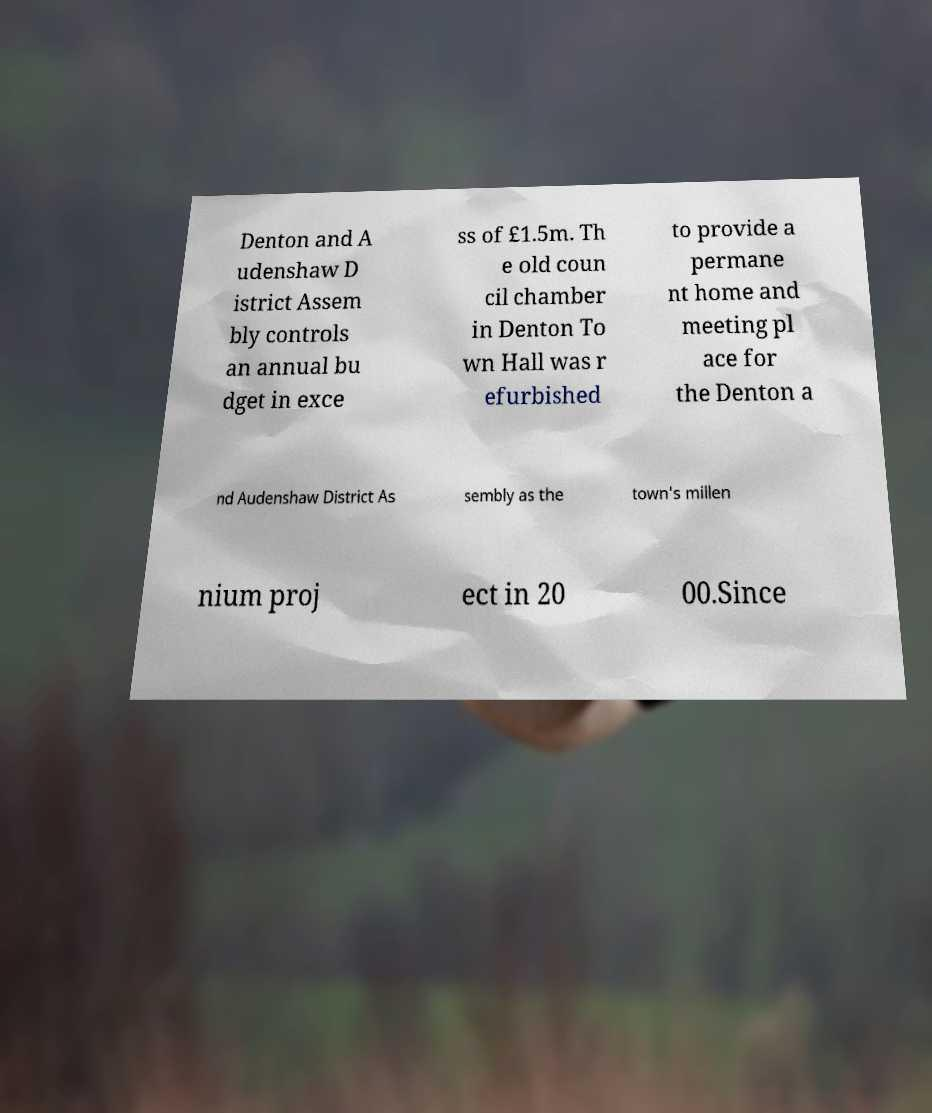Can you accurately transcribe the text from the provided image for me? Denton and A udenshaw D istrict Assem bly controls an annual bu dget in exce ss of £1.5m. Th e old coun cil chamber in Denton To wn Hall was r efurbished to provide a permane nt home and meeting pl ace for the Denton a nd Audenshaw District As sembly as the town's millen nium proj ect in 20 00.Since 